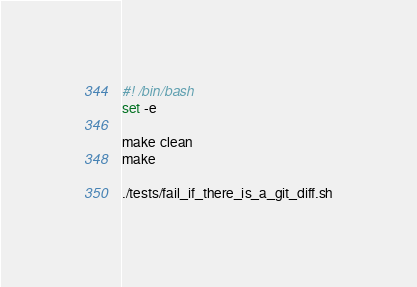<code> <loc_0><loc_0><loc_500><loc_500><_Bash_>#! /bin/bash
set -e

make clean
make

./tests/fail_if_there_is_a_git_diff.sh
</code> 